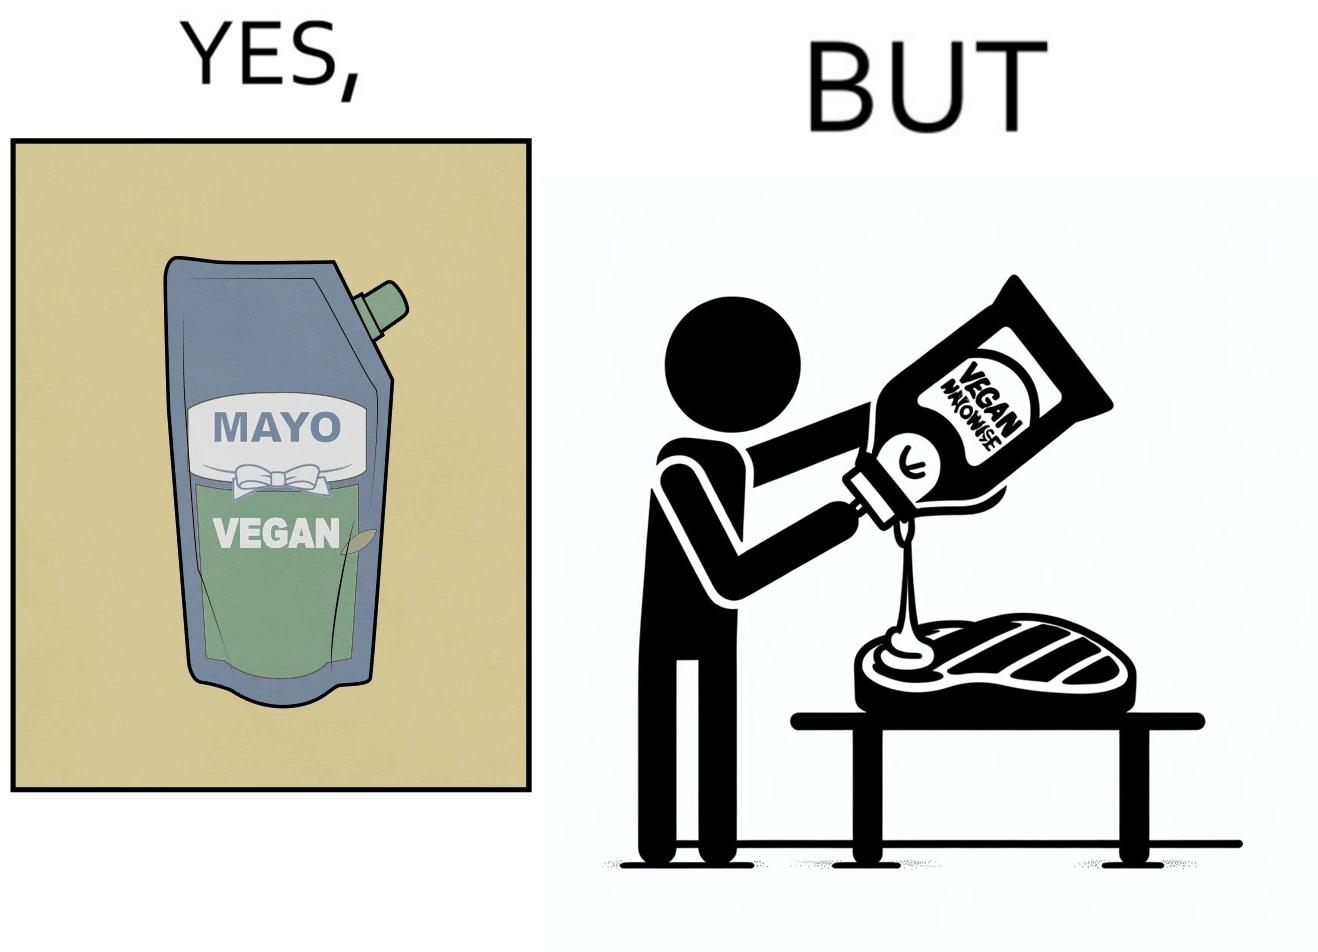Compare the left and right sides of this image. In the left part of the image: a vegan mayo sauce packet In the right part of the image: pouring vegan mayo sauce from a packet on a rib steak 